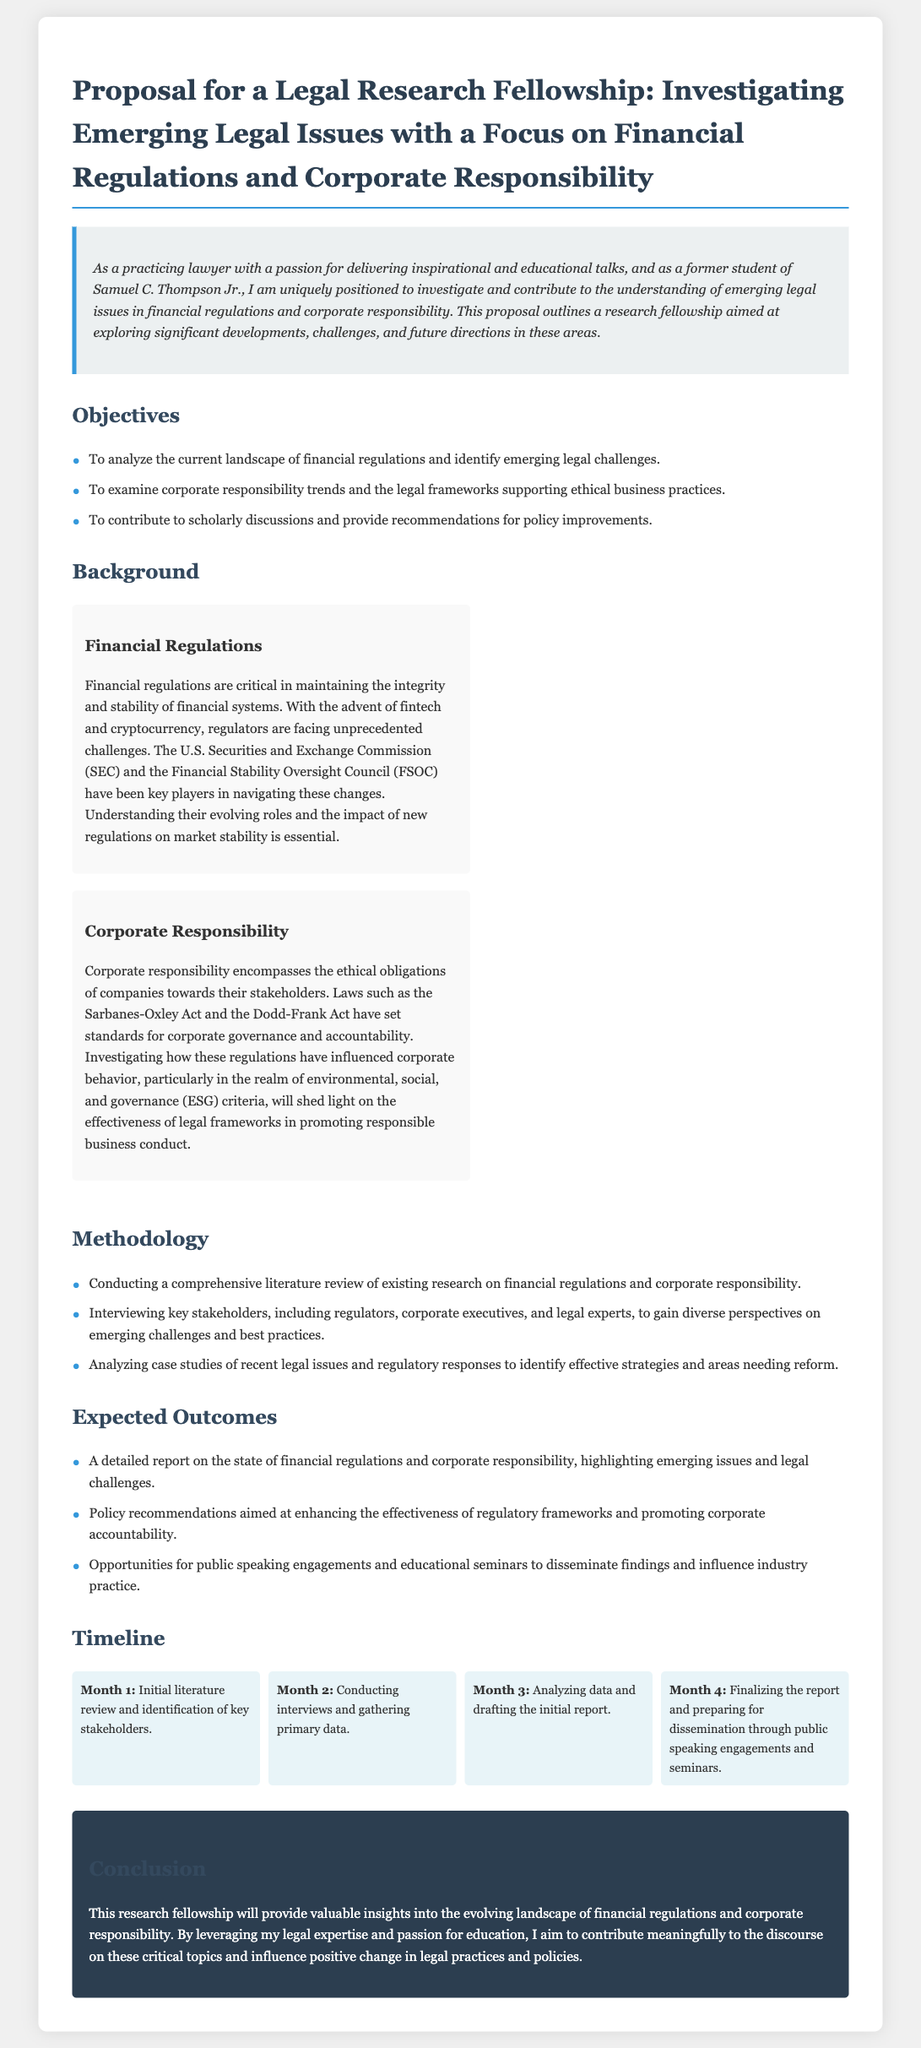What are the main objectives of the proposal? The proposal lists three main objectives related to financial regulations and corporate responsibility.
Answer: Analyze the current landscape, examine trends, provide recommendations What is the focus of the Legal Research Fellowship? The proposal specifically mentions the focus areas for the fellowship investigation.
Answer: Financial regulations and corporate responsibility Which act is mentioned in connection to corporate responsibility? The document references specific legal frameworks supporting corporate responsibility.
Answer: Sarbanes-Oxley Act What is the duration for the data analysis and report drafting phase? The timeline indicates how long the analysis and drafting process will take.
Answer: 1 month What is the expected outcome of the research fellowship? The document specifies a detailed report as one of the expected outcomes.
Answer: A detailed report Who is the target for public speaking engagements according to the expected outcomes? The document highlights who would benefit from the public speaking opportunities.
Answer: Industry practice 